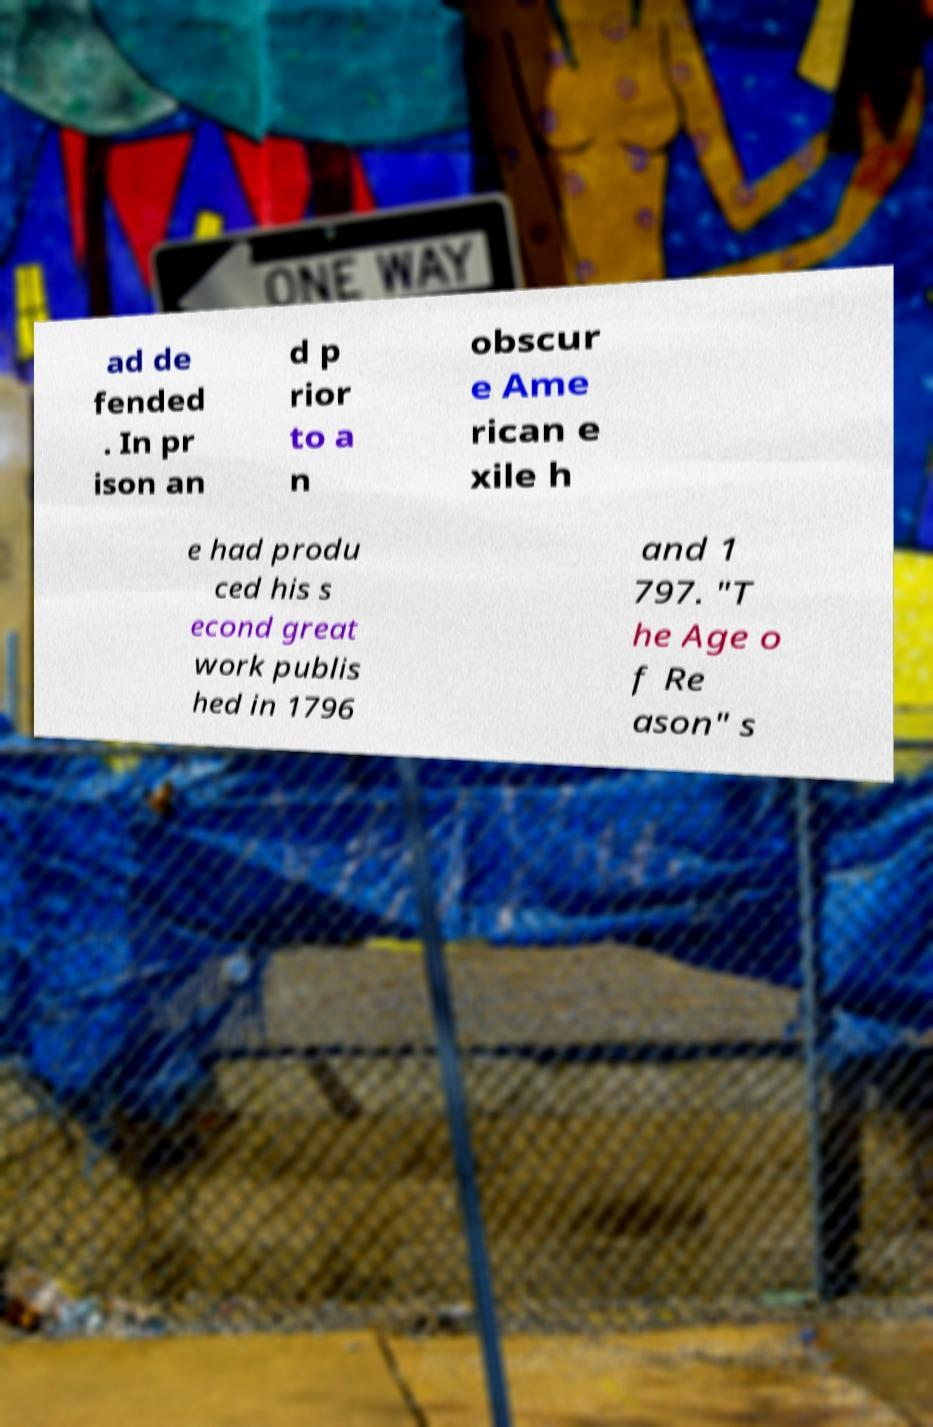Please identify and transcribe the text found in this image. ad de fended . In pr ison an d p rior to a n obscur e Ame rican e xile h e had produ ced his s econd great work publis hed in 1796 and 1 797. "T he Age o f Re ason" s 